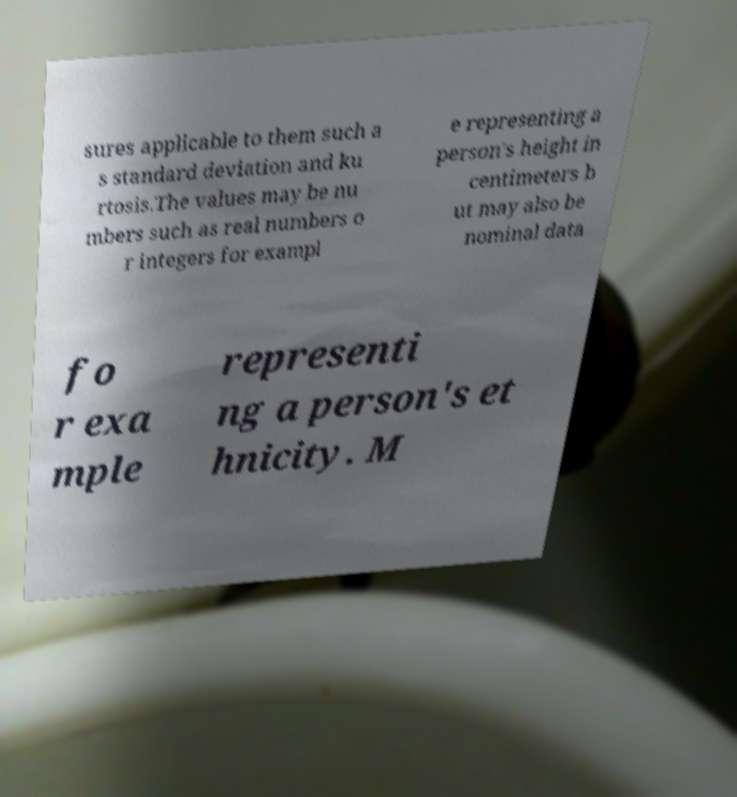Please identify and transcribe the text found in this image. sures applicable to them such a s standard deviation and ku rtosis.The values may be nu mbers such as real numbers o r integers for exampl e representing a person's height in centimeters b ut may also be nominal data fo r exa mple representi ng a person's et hnicity. M 